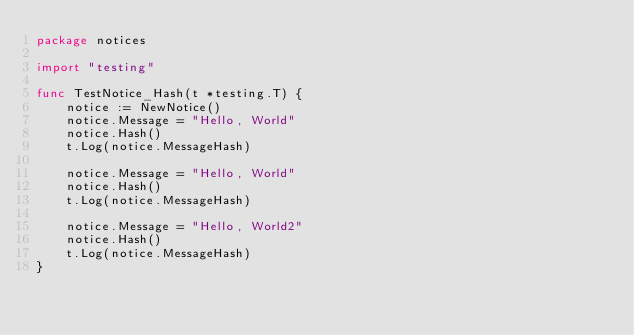<code> <loc_0><loc_0><loc_500><loc_500><_Go_>package notices

import "testing"

func TestNotice_Hash(t *testing.T) {
	notice := NewNotice()
	notice.Message = "Hello, World"
	notice.Hash()
	t.Log(notice.MessageHash)

	notice.Message = "Hello, World"
	notice.Hash()
	t.Log(notice.MessageHash)

	notice.Message = "Hello, World2"
	notice.Hash()
	t.Log(notice.MessageHash)
}
</code> 